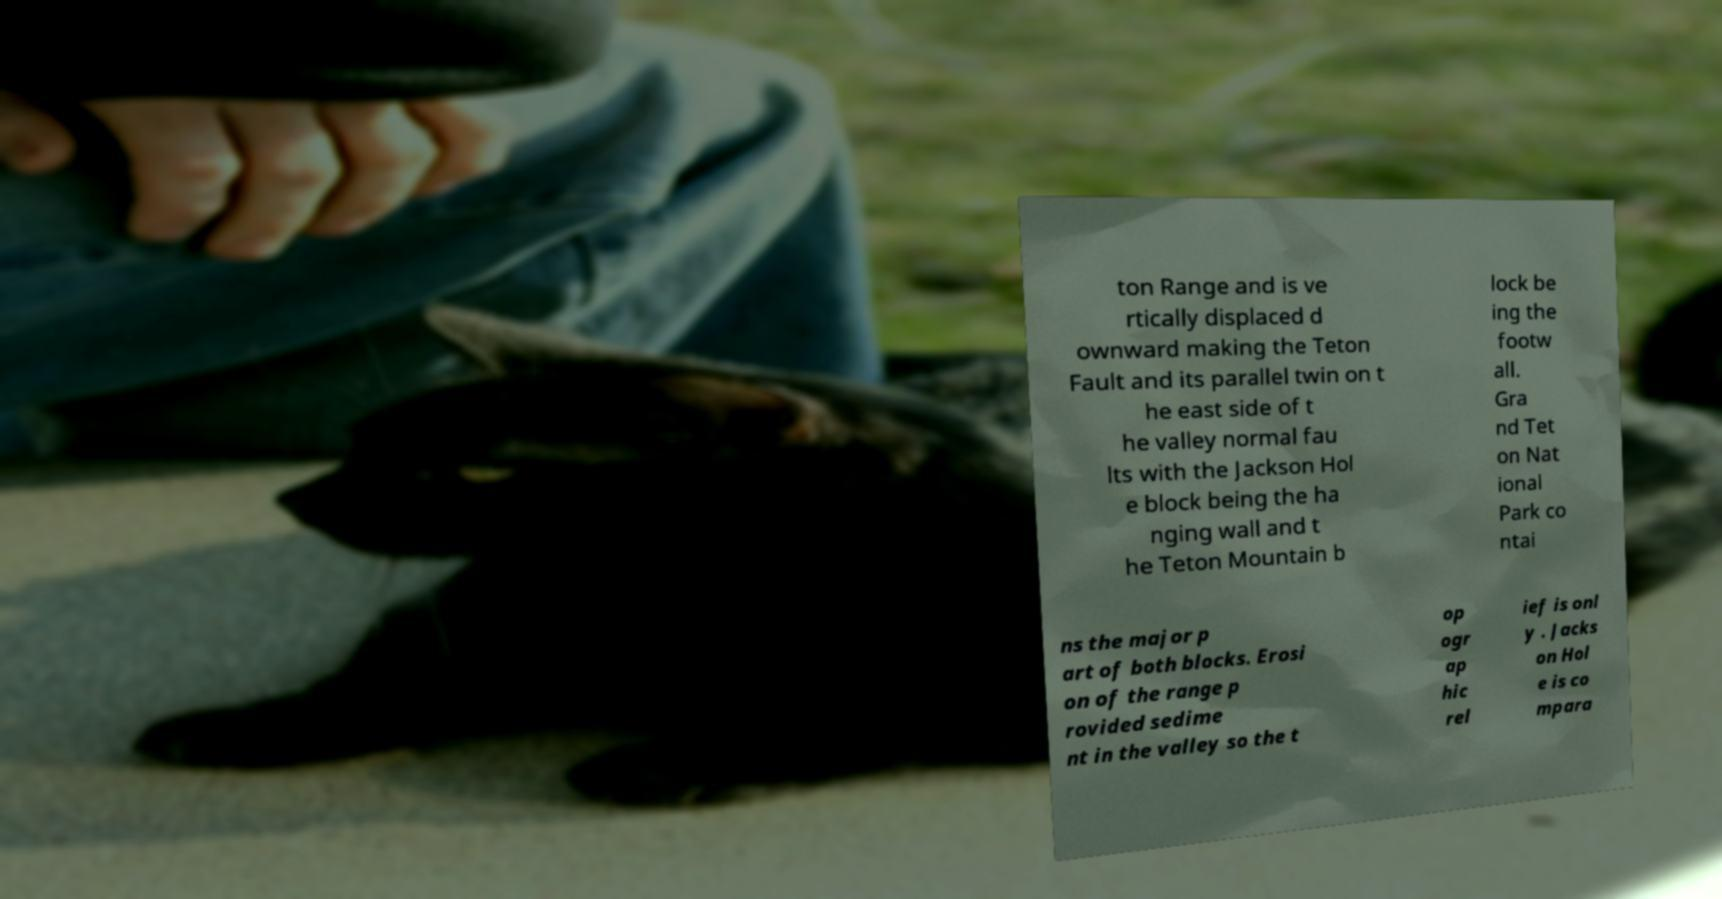Can you accurately transcribe the text from the provided image for me? ton Range and is ve rtically displaced d ownward making the Teton Fault and its parallel twin on t he east side of t he valley normal fau lts with the Jackson Hol e block being the ha nging wall and t he Teton Mountain b lock be ing the footw all. Gra nd Tet on Nat ional Park co ntai ns the major p art of both blocks. Erosi on of the range p rovided sedime nt in the valley so the t op ogr ap hic rel ief is onl y . Jacks on Hol e is co mpara 